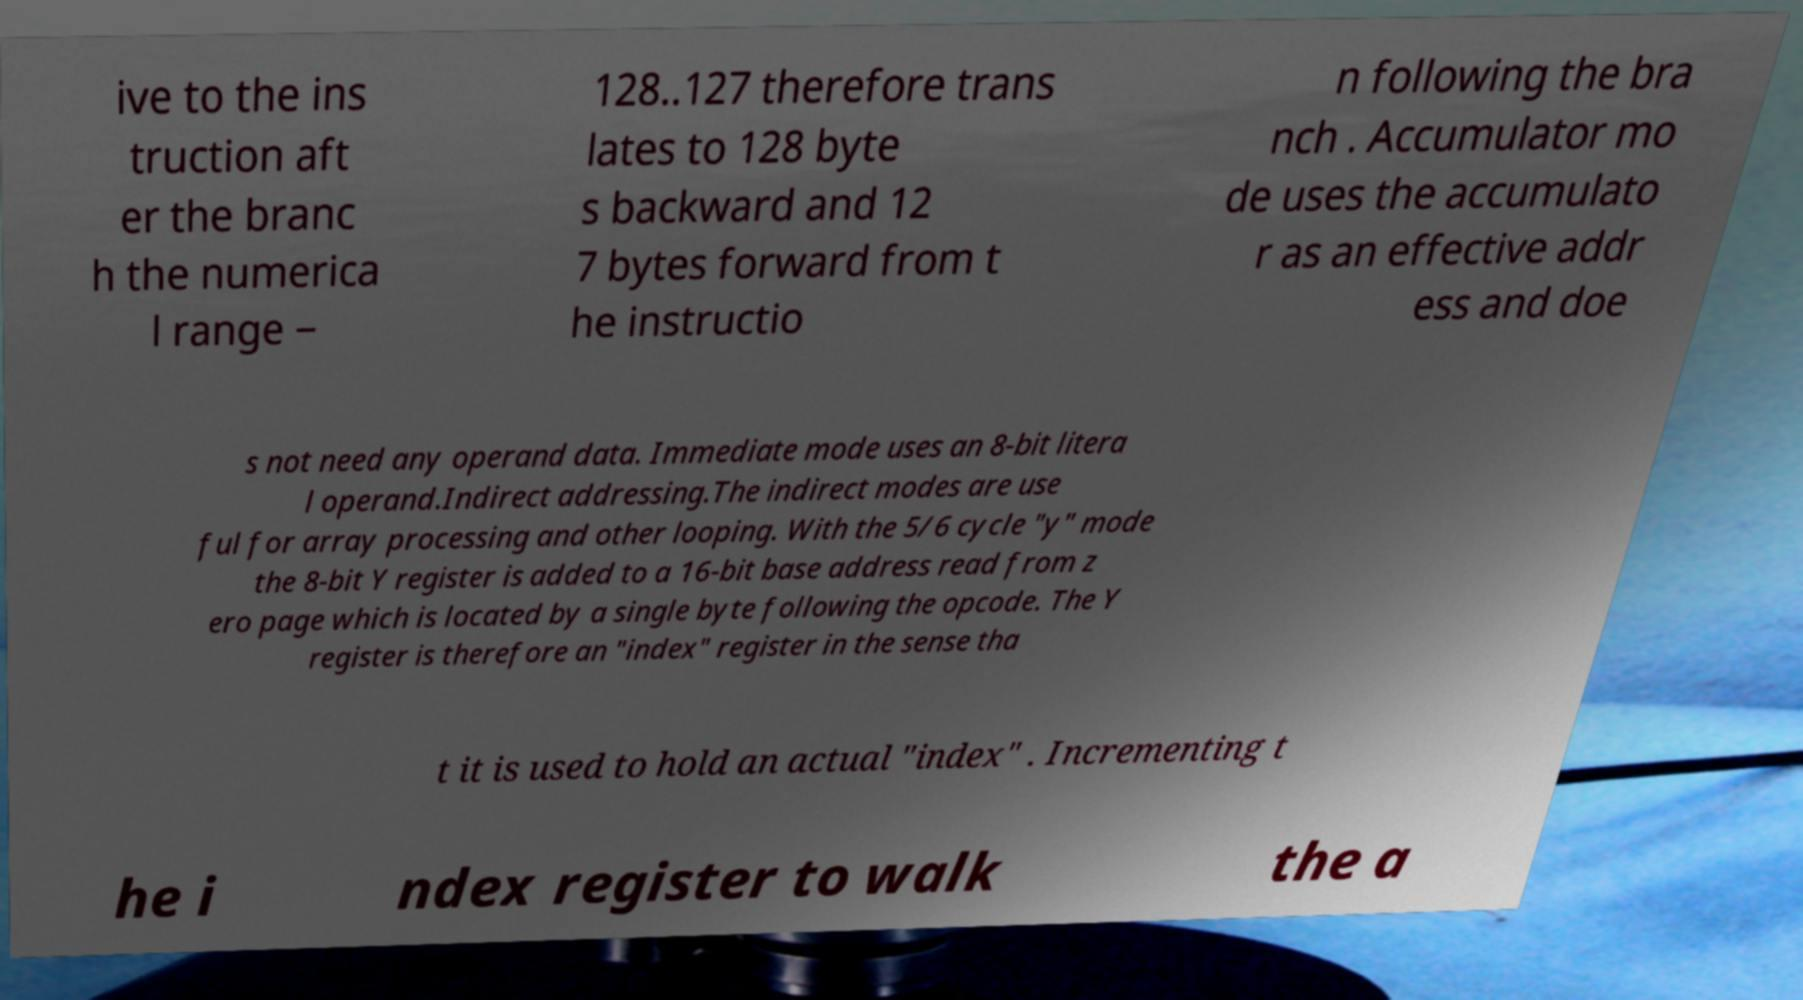Please read and relay the text visible in this image. What does it say? ive to the ins truction aft er the branc h the numerica l range − 128..127 therefore trans lates to 128 byte s backward and 12 7 bytes forward from t he instructio n following the bra nch . Accumulator mo de uses the accumulato r as an effective addr ess and doe s not need any operand data. Immediate mode uses an 8-bit litera l operand.Indirect addressing.The indirect modes are use ful for array processing and other looping. With the 5/6 cycle "y" mode the 8-bit Y register is added to a 16-bit base address read from z ero page which is located by a single byte following the opcode. The Y register is therefore an "index" register in the sense tha t it is used to hold an actual "index" . Incrementing t he i ndex register to walk the a 